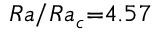<formula> <loc_0><loc_0><loc_500><loc_500>R a / R a _ { c } { = } 4 . 5 7</formula> 